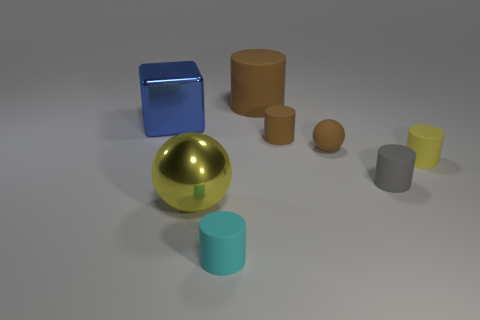Subtract all large brown cylinders. How many cylinders are left? 4 Subtract all cyan cylinders. How many cylinders are left? 4 Subtract all balls. How many objects are left? 6 Add 1 tiny cyan cylinders. How many objects exist? 9 Subtract 1 blue cubes. How many objects are left? 7 Subtract 1 cylinders. How many cylinders are left? 4 Subtract all brown cylinders. Subtract all brown blocks. How many cylinders are left? 3 Subtract all brown blocks. How many blue balls are left? 0 Subtract all cyan things. Subtract all large metal blocks. How many objects are left? 6 Add 2 tiny cyan matte cylinders. How many tiny cyan matte cylinders are left? 3 